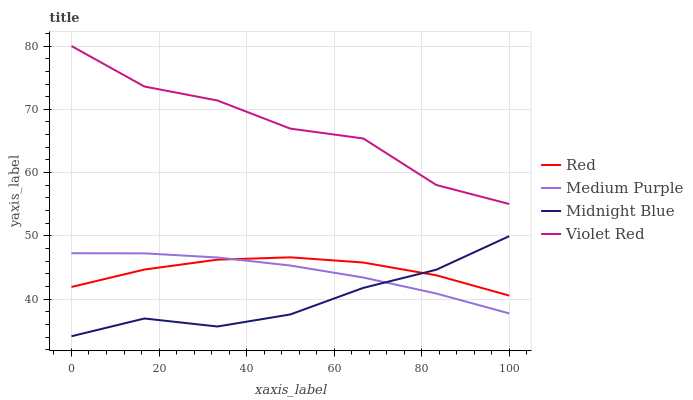Does Midnight Blue have the minimum area under the curve?
Answer yes or no. Yes. Does Violet Red have the maximum area under the curve?
Answer yes or no. Yes. Does Violet Red have the minimum area under the curve?
Answer yes or no. No. Does Midnight Blue have the maximum area under the curve?
Answer yes or no. No. Is Medium Purple the smoothest?
Answer yes or no. Yes. Is Violet Red the roughest?
Answer yes or no. Yes. Is Midnight Blue the smoothest?
Answer yes or no. No. Is Midnight Blue the roughest?
Answer yes or no. No. Does Midnight Blue have the lowest value?
Answer yes or no. Yes. Does Violet Red have the lowest value?
Answer yes or no. No. Does Violet Red have the highest value?
Answer yes or no. Yes. Does Midnight Blue have the highest value?
Answer yes or no. No. Is Medium Purple less than Violet Red?
Answer yes or no. Yes. Is Violet Red greater than Midnight Blue?
Answer yes or no. Yes. Does Red intersect Medium Purple?
Answer yes or no. Yes. Is Red less than Medium Purple?
Answer yes or no. No. Is Red greater than Medium Purple?
Answer yes or no. No. Does Medium Purple intersect Violet Red?
Answer yes or no. No. 